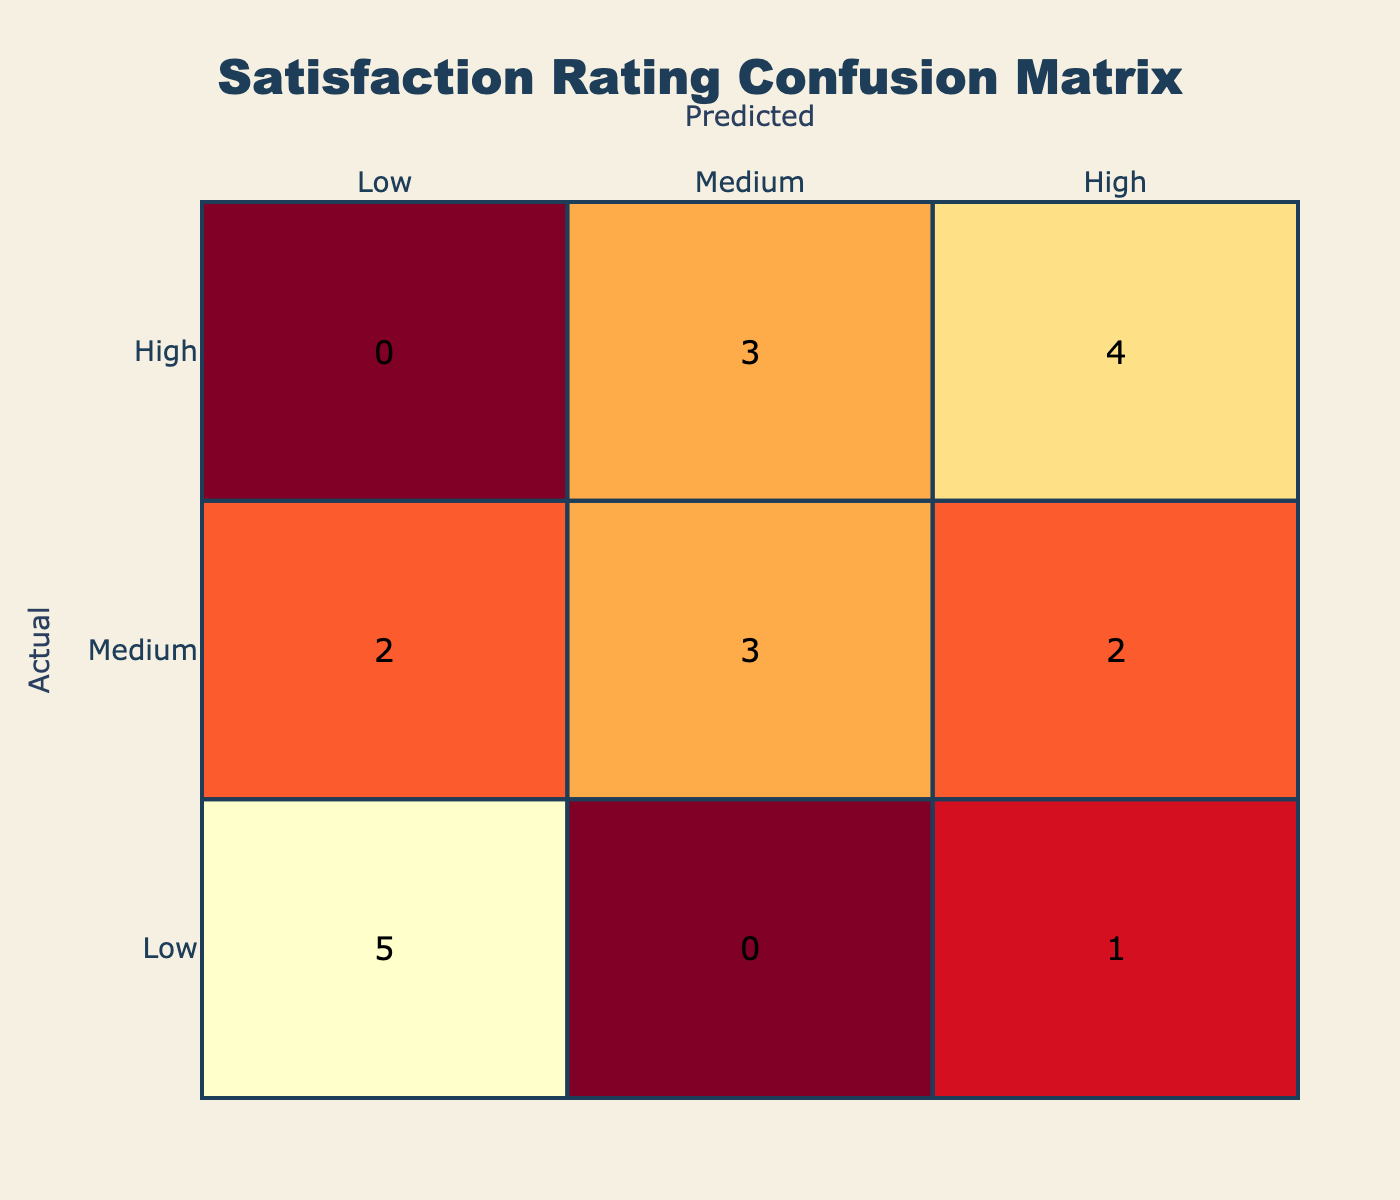What is the number of actual high satisfaction ratings predicted as high? Referring to the confusion matrix, we look at the 'High' row and 'High' column intersection. There are 6 instances of actual high satisfaction ratings that were predicted to be high.
Answer: 6 What is the total number of actual low satisfaction ratings? In the confusion matrix, we sum the values in the 'Low' row, which includes predictions of low, medium, and high satisfaction. The sum of these values is 4 (2 low predicted as low, 1 low predicted as medium, and 1 low predicted as high).
Answer: 4 Are there any cases where low actual satisfaction was predicted as high? Checking the confusion matrix, there is one instance where actual low satisfaction was predicted as high in the 'Cave Exploration' category.
Answer: Yes What is the combined total of high satisfaction ratings predicted as low and medium? We look at the 'High' column and sum the instances predicted as low (1) and medium (3). The total is 4 (1 low predicted and 3 medium predicted).
Answer: 4 How many instances of medium actual satisfaction were inaccurately predicted as high? From the confusion matrix, we check the 'Medium' row and 'High' column. There are two instances of medium satisfaction that were predicted as high.
Answer: 2 Which trip type had the highest number of accurate predictions for high satisfaction? Analyzing the matrix, we check each trip type's row for high predictions. Both 'Cave Exploration' and 'Landscape Photography' have a total of 3 accurate high predictions.
Answer: Cave Exploration and Landscape Photography What is the proportion of instances where high satisfaction ratings were predicted as low? Looking at the confusion matrix, we find that there is one instance of high ratings being predicted as low. Since the total instances of high ratings are 6, the proportion is 1 out of 6, or approximately 16.67%.
Answer: Approximately 16.67% Can you provide the difference in the number of predicted low actual satisfaction ratings versus predicted medium actual satisfaction ratings? In the confusion matrix, we see that 6 instances are predicted as low for actual satisfaction ratings (2 low predicted as low, 2 low predicted as medium, and 2 low predicted as high) compared to 6 predicted as medium for actual satisfaction ratings. The difference is 0.
Answer: 0 What percentage of low satisfaction ratings were predicted correctly as low? In the 'Low' row of the confusion matrix, there are 2 instances predicted correctly as low out of a total of 4 low satisfaction ratings. This results in a percentage of (2/4) * 100 = 50%.
Answer: 50% 